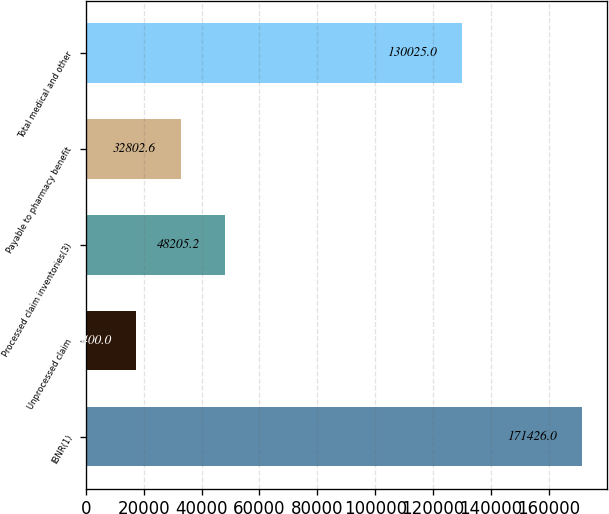Convert chart to OTSL. <chart><loc_0><loc_0><loc_500><loc_500><bar_chart><fcel>IBNR(1)<fcel>Unprocessed claim<fcel>Processed claim inventories(3)<fcel>Payable to pharmacy benefit<fcel>Total medical and other<nl><fcel>171426<fcel>17400<fcel>48205.2<fcel>32802.6<fcel>130025<nl></chart> 